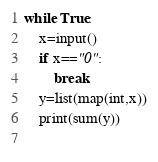<code> <loc_0><loc_0><loc_500><loc_500><_Python_>while True:
    x=input()
    if x=="0":
        break
    y=list(map(int,x))
    print(sum(y))
    
</code> 